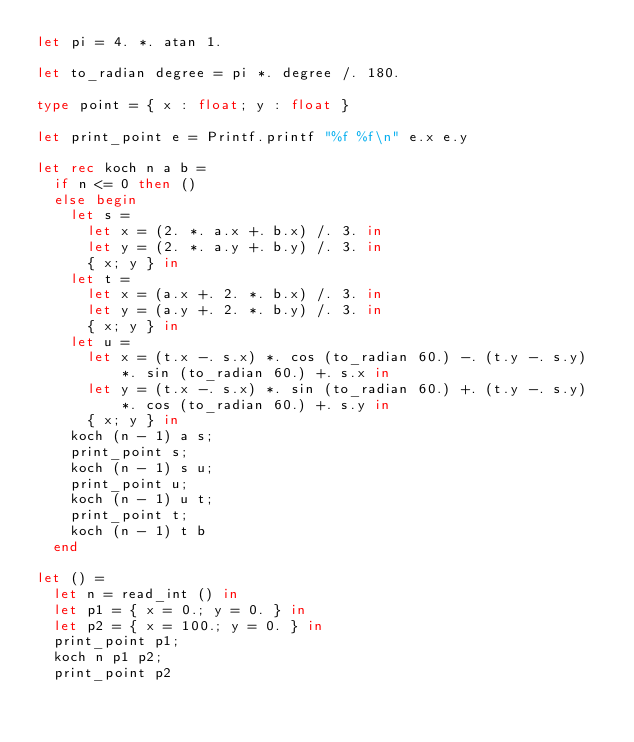Convert code to text. <code><loc_0><loc_0><loc_500><loc_500><_OCaml_>let pi = 4. *. atan 1.

let to_radian degree = pi *. degree /. 180.

type point = { x : float; y : float }

let print_point e = Printf.printf "%f %f\n" e.x e.y

let rec koch n a b =
  if n <= 0 then ()
  else begin
    let s =
      let x = (2. *. a.x +. b.x) /. 3. in
      let y = (2. *. a.y +. b.y) /. 3. in
      { x; y } in
    let t =
      let x = (a.x +. 2. *. b.x) /. 3. in
      let y = (a.y +. 2. *. b.y) /. 3. in
      { x; y } in
    let u =
      let x = (t.x -. s.x) *. cos (to_radian 60.) -. (t.y -. s.y) *. sin (to_radian 60.) +. s.x in
      let y = (t.x -. s.x) *. sin (to_radian 60.) +. (t.y -. s.y) *. cos (to_radian 60.) +. s.y in
      { x; y } in
    koch (n - 1) a s;
    print_point s;
    koch (n - 1) s u;
    print_point u;
    koch (n - 1) u t;
    print_point t;
    koch (n - 1) t b
  end

let () =
  let n = read_int () in
  let p1 = { x = 0.; y = 0. } in
  let p2 = { x = 100.; y = 0. } in
  print_point p1;
  koch n p1 p2;
  print_point p2</code> 